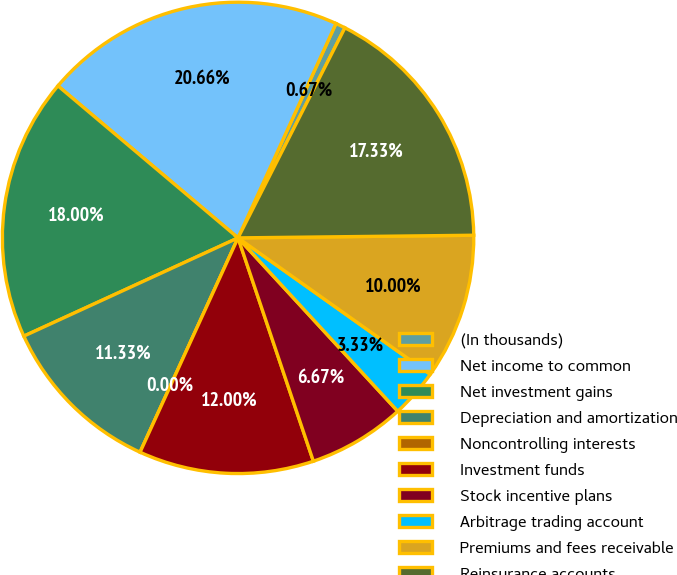Convert chart. <chart><loc_0><loc_0><loc_500><loc_500><pie_chart><fcel>(In thousands)<fcel>Net income to common<fcel>Net investment gains<fcel>Depreciation and amortization<fcel>Noncontrolling interests<fcel>Investment funds<fcel>Stock incentive plans<fcel>Arbitrage trading account<fcel>Premiums and fees receivable<fcel>Reinsurance accounts<nl><fcel>0.67%<fcel>20.66%<fcel>18.0%<fcel>11.33%<fcel>0.0%<fcel>12.0%<fcel>6.67%<fcel>3.33%<fcel>10.0%<fcel>17.33%<nl></chart> 